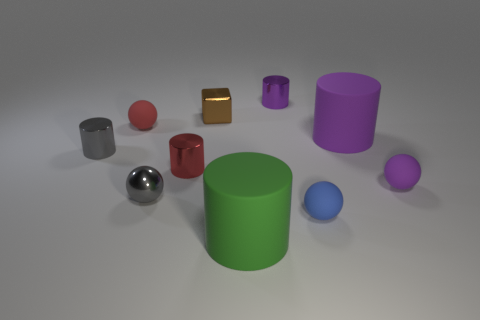Subtract all metallic balls. How many balls are left? 3 Subtract all purple spheres. How many purple cylinders are left? 2 Subtract all purple spheres. How many spheres are left? 3 Subtract 2 balls. How many balls are left? 2 Subtract all brown cylinders. Subtract all yellow balls. How many cylinders are left? 5 Subtract all blocks. How many objects are left? 9 Subtract all red metal blocks. Subtract all gray metal spheres. How many objects are left? 9 Add 4 small brown shiny blocks. How many small brown shiny blocks are left? 5 Add 5 purple metal cylinders. How many purple metal cylinders exist? 6 Subtract 1 red spheres. How many objects are left? 9 